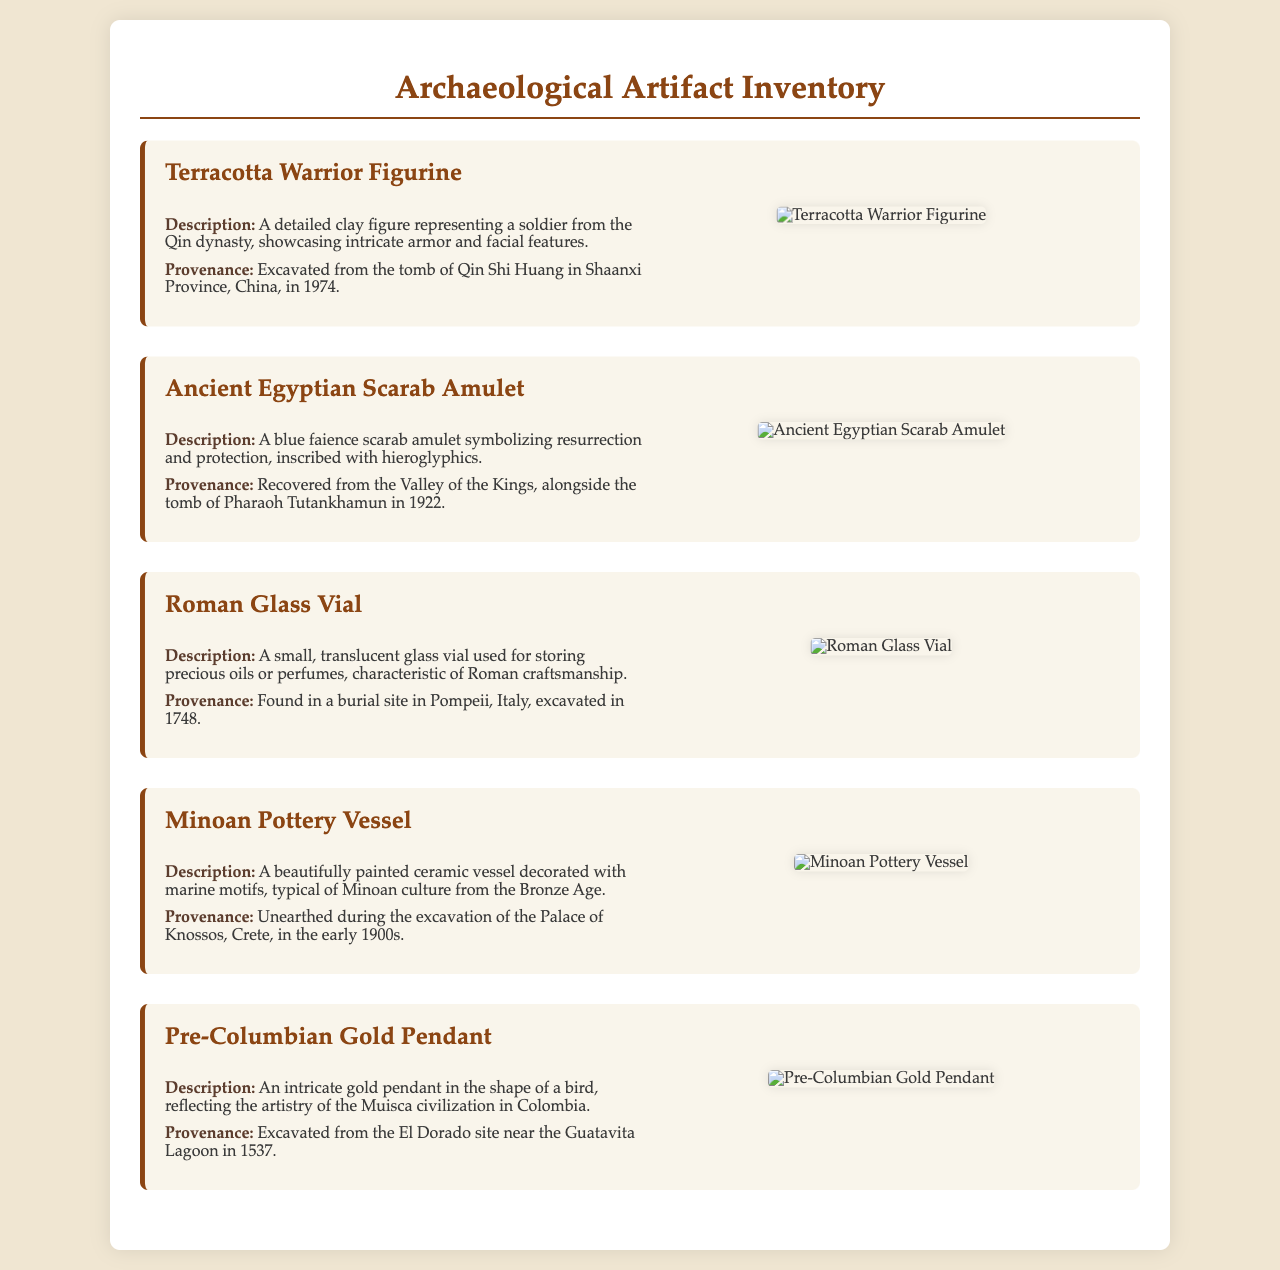What is the title of the document? The title appears at the top of the document and is "Archaeological Artifact Inventory."
Answer: Archaeological Artifact Inventory In which province was the Terracotta Warrior Figurine excavated? The provenance section for the Terracotta Warrior Figurine indicates it was excavated in "Shaanxi Province, China."
Answer: Shaanxi Province, China What year was the Ancient Egyptian Scarab Amulet recovered? The provenance for the Ancient Egyptian Scarab Amulet states it was recovered in "1922."
Answer: 1922 What was the main material of the Roman Glass Vial? The description of the Roman Glass Vial notes it is made of "glass."
Answer: glass Which civilization is associated with the Pre-Columbian Gold Pendant? The description of the Pre-Columbian Gold Pendant mentions it reflects the artistry of the "Muisca civilization."
Answer: Muisca civilization What type of motifs decorate the Minoan Pottery Vessel? The description of the Minoan Pottery Vessel refers to it being decorated with "marine motifs."
Answer: marine motifs How many artifacts are listed in the document? The document lists a total of "five" artifacts.
Answer: five What is the primary purpose of this document? The document serves as an inventory for archaeologists to catalog and describe artifacts, thus its purpose is to provide organization and documentation.
Answer: inventory What visual element is used to represent each artifact? The document includes "photograph attachments" of each artifact, visually representing them.
Answer: photograph attachments 